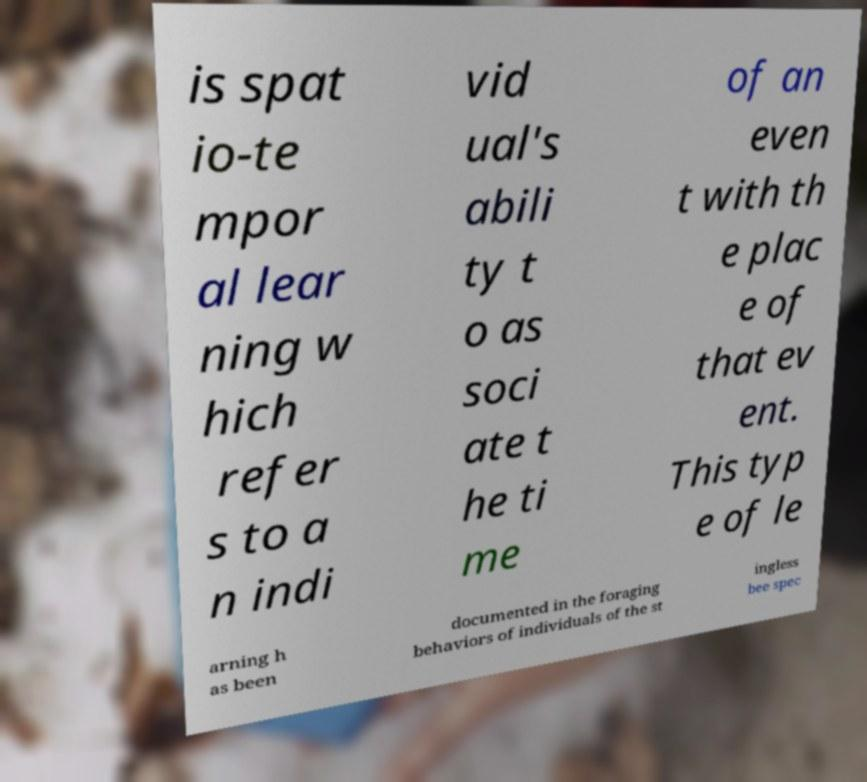I need the written content from this picture converted into text. Can you do that? is spat io-te mpor al lear ning w hich refer s to a n indi vid ual's abili ty t o as soci ate t he ti me of an even t with th e plac e of that ev ent. This typ e of le arning h as been documented in the foraging behaviors of individuals of the st ingless bee spec 